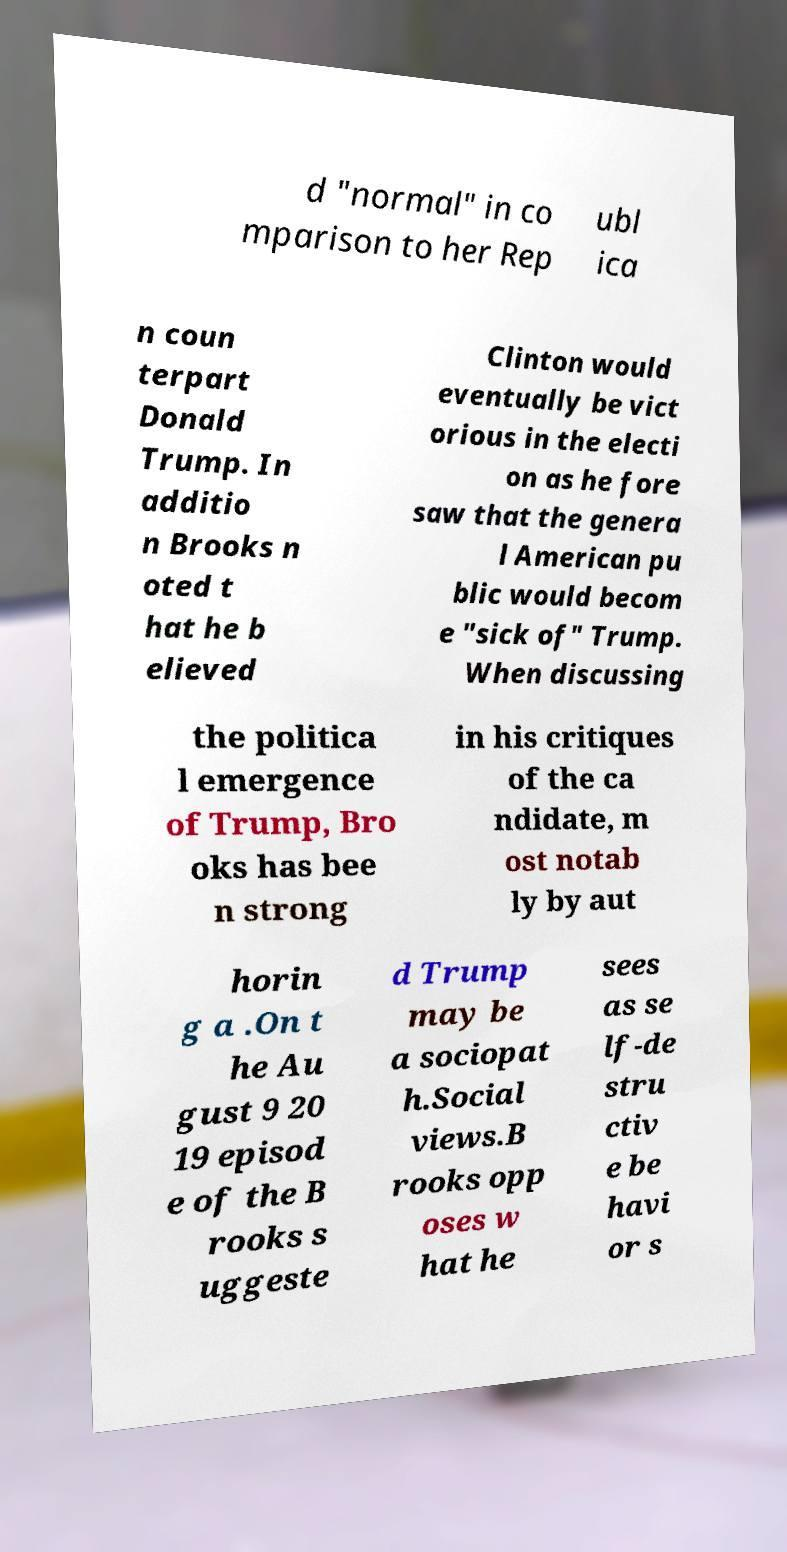Please identify and transcribe the text found in this image. d "normal" in co mparison to her Rep ubl ica n coun terpart Donald Trump. In additio n Brooks n oted t hat he b elieved Clinton would eventually be vict orious in the electi on as he fore saw that the genera l American pu blic would becom e "sick of" Trump. When discussing the politica l emergence of Trump, Bro oks has bee n strong in his critiques of the ca ndidate, m ost notab ly by aut horin g a .On t he Au gust 9 20 19 episod e of the B rooks s uggeste d Trump may be a sociopat h.Social views.B rooks opp oses w hat he sees as se lf-de stru ctiv e be havi or s 